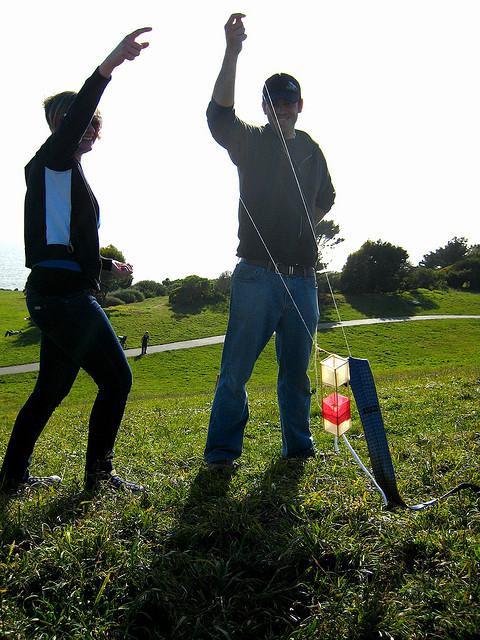What are the people holding?
Write a very short answer. Kite. Do both persons have an arm up?
Quick response, please. Yes. What are they trying to do?
Answer briefly. Fly kite. 